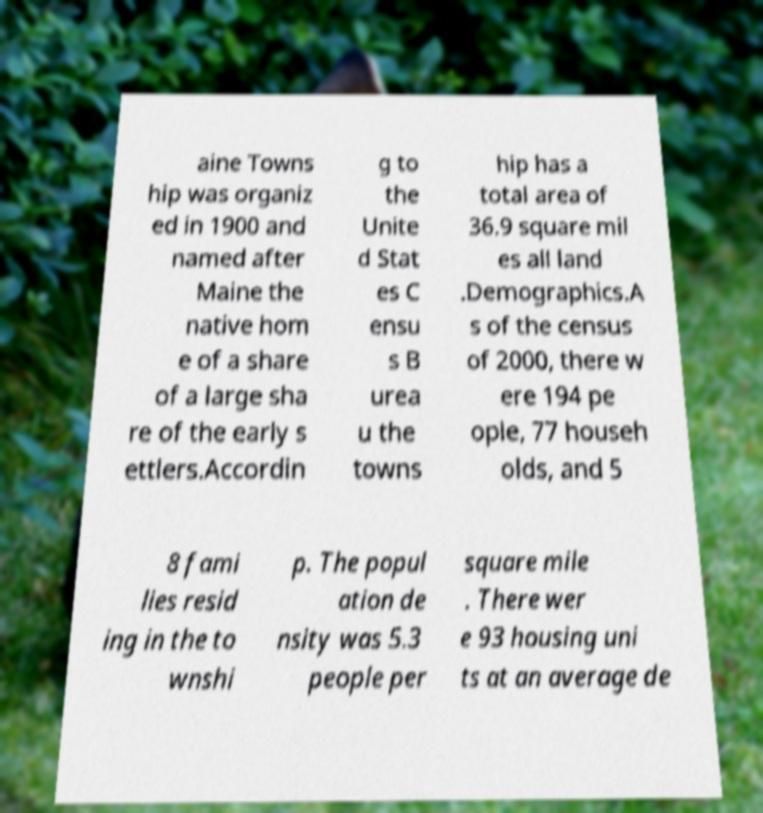There's text embedded in this image that I need extracted. Can you transcribe it verbatim? aine Towns hip was organiz ed in 1900 and named after Maine the native hom e of a share of a large sha re of the early s ettlers.Accordin g to the Unite d Stat es C ensu s B urea u the towns hip has a total area of 36.9 square mil es all land .Demographics.A s of the census of 2000, there w ere 194 pe ople, 77 househ olds, and 5 8 fami lies resid ing in the to wnshi p. The popul ation de nsity was 5.3 people per square mile . There wer e 93 housing uni ts at an average de 